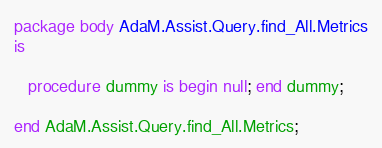<code> <loc_0><loc_0><loc_500><loc_500><_Ada_>
package body AdaM.Assist.Query.find_All.Metrics
is

   procedure dummy is begin null; end dummy;

end AdaM.Assist.Query.find_All.Metrics;
</code> 